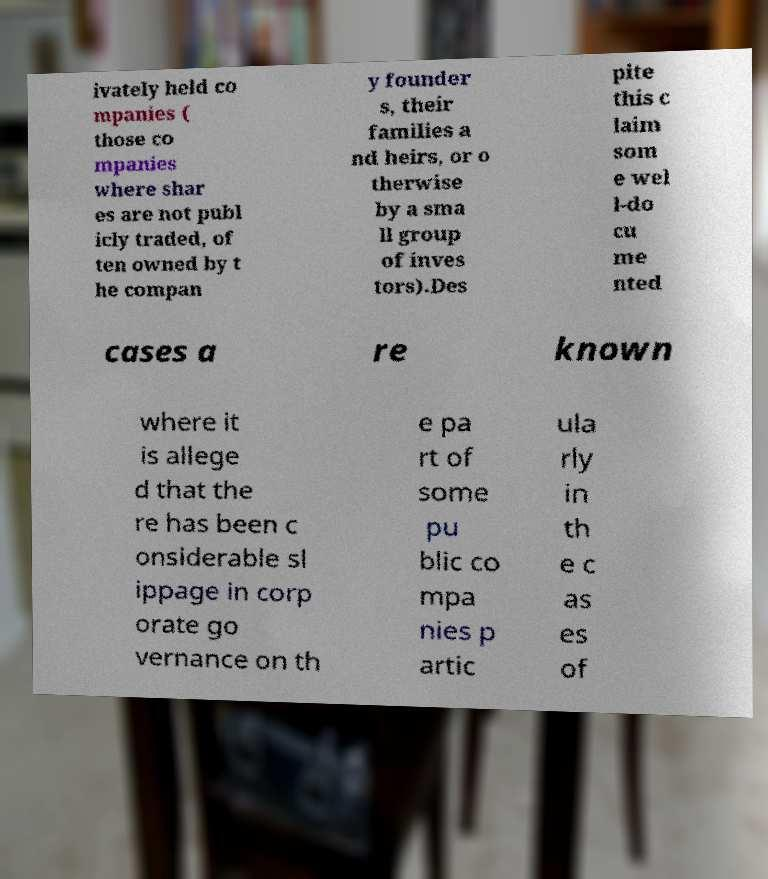Can you accurately transcribe the text from the provided image for me? ivately held co mpanies ( those co mpanies where shar es are not publ icly traded, of ten owned by t he compan y founder s, their families a nd heirs, or o therwise by a sma ll group of inves tors).Des pite this c laim som e wel l-do cu me nted cases a re known where it is allege d that the re has been c onsiderable sl ippage in corp orate go vernance on th e pa rt of some pu blic co mpa nies p artic ula rly in th e c as es of 